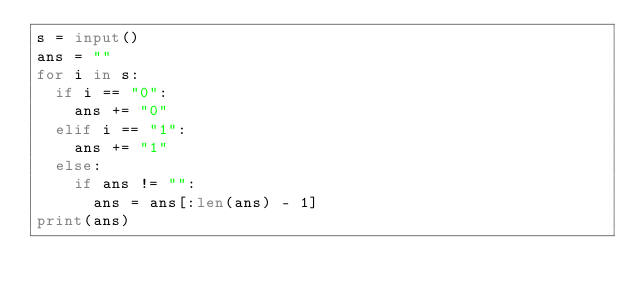Convert code to text. <code><loc_0><loc_0><loc_500><loc_500><_Python_>s = input()
ans = ""
for i in s:
  if i == "0":
    ans += "0"
  elif i == "1":
    ans += "1"
  else:
    if ans != "":
      ans = ans[:len(ans) - 1]
print(ans)</code> 